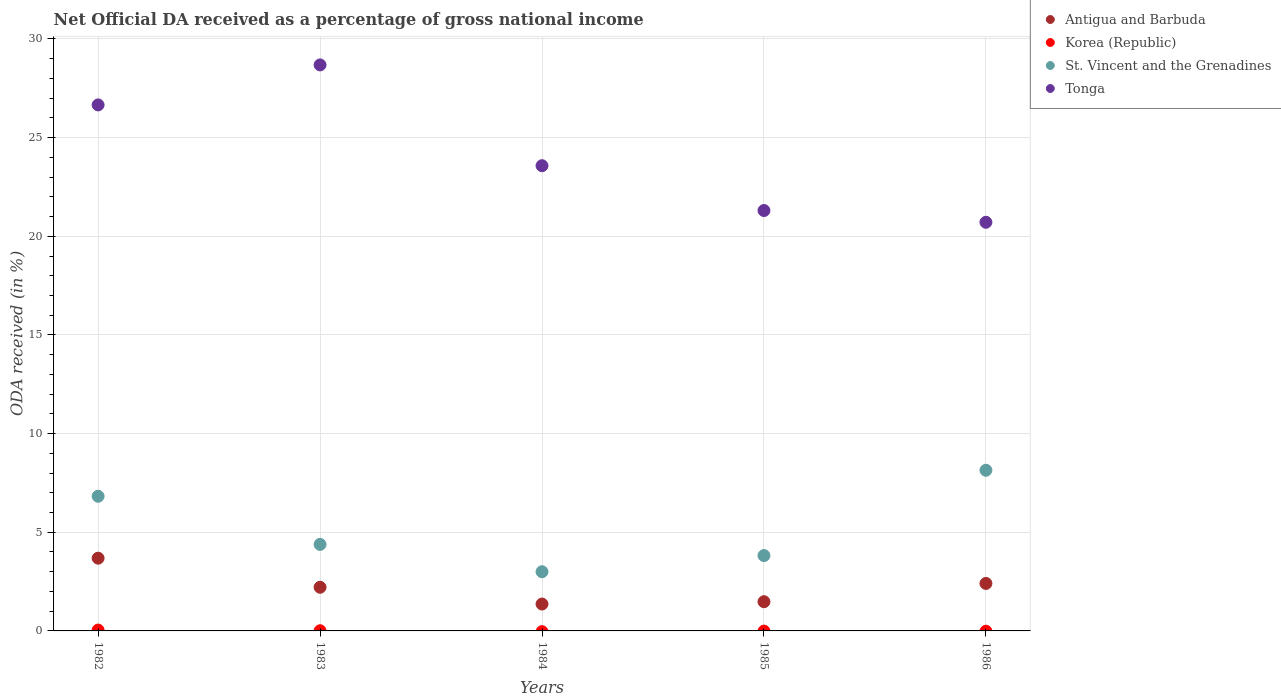Is the number of dotlines equal to the number of legend labels?
Provide a succinct answer. No. What is the net official DA received in Korea (Republic) in 1985?
Keep it short and to the point. 0. Across all years, what is the maximum net official DA received in St. Vincent and the Grenadines?
Offer a very short reply. 8.14. Across all years, what is the minimum net official DA received in Korea (Republic)?
Make the answer very short. 0. In which year was the net official DA received in Tonga maximum?
Give a very brief answer. 1983. What is the total net official DA received in St. Vincent and the Grenadines in the graph?
Offer a very short reply. 26.17. What is the difference between the net official DA received in Tonga in 1982 and that in 1983?
Give a very brief answer. -2.03. What is the difference between the net official DA received in St. Vincent and the Grenadines in 1984 and the net official DA received in Korea (Republic) in 1982?
Make the answer very short. 2.96. What is the average net official DA received in Antigua and Barbuda per year?
Provide a succinct answer. 2.23. In the year 1983, what is the difference between the net official DA received in Korea (Republic) and net official DA received in Antigua and Barbuda?
Your answer should be compact. -2.2. What is the ratio of the net official DA received in Korea (Republic) in 1982 to that in 1983?
Give a very brief answer. 4.91. Is the net official DA received in St. Vincent and the Grenadines in 1983 less than that in 1985?
Offer a very short reply. No. What is the difference between the highest and the second highest net official DA received in Antigua and Barbuda?
Give a very brief answer. 1.28. What is the difference between the highest and the lowest net official DA received in Antigua and Barbuda?
Make the answer very short. 2.32. In how many years, is the net official DA received in Tonga greater than the average net official DA received in Tonga taken over all years?
Ensure brevity in your answer.  2. Is it the case that in every year, the sum of the net official DA received in Antigua and Barbuda and net official DA received in Korea (Republic)  is greater than the sum of net official DA received in St. Vincent and the Grenadines and net official DA received in Tonga?
Offer a terse response. No. Is it the case that in every year, the sum of the net official DA received in Antigua and Barbuda and net official DA received in St. Vincent and the Grenadines  is greater than the net official DA received in Korea (Republic)?
Your answer should be compact. Yes. Is the net official DA received in Korea (Republic) strictly less than the net official DA received in Tonga over the years?
Your answer should be compact. Yes. How many years are there in the graph?
Offer a terse response. 5. What is the difference between two consecutive major ticks on the Y-axis?
Provide a short and direct response. 5. Are the values on the major ticks of Y-axis written in scientific E-notation?
Your answer should be compact. No. Does the graph contain any zero values?
Give a very brief answer. Yes. Where does the legend appear in the graph?
Offer a terse response. Top right. How are the legend labels stacked?
Your response must be concise. Vertical. What is the title of the graph?
Provide a short and direct response. Net Official DA received as a percentage of gross national income. Does "Czech Republic" appear as one of the legend labels in the graph?
Give a very brief answer. No. What is the label or title of the X-axis?
Provide a succinct answer. Years. What is the label or title of the Y-axis?
Provide a short and direct response. ODA received (in %). What is the ODA received (in %) of Antigua and Barbuda in 1982?
Provide a succinct answer. 3.69. What is the ODA received (in %) of Korea (Republic) in 1982?
Keep it short and to the point. 0.04. What is the ODA received (in %) of St. Vincent and the Grenadines in 1982?
Your answer should be very brief. 6.83. What is the ODA received (in %) in Tonga in 1982?
Keep it short and to the point. 26.66. What is the ODA received (in %) of Antigua and Barbuda in 1983?
Offer a terse response. 2.21. What is the ODA received (in %) of Korea (Republic) in 1983?
Give a very brief answer. 0.01. What is the ODA received (in %) of St. Vincent and the Grenadines in 1983?
Your answer should be compact. 4.38. What is the ODA received (in %) of Tonga in 1983?
Ensure brevity in your answer.  28.69. What is the ODA received (in %) in Antigua and Barbuda in 1984?
Your answer should be very brief. 1.36. What is the ODA received (in %) of St. Vincent and the Grenadines in 1984?
Offer a very short reply. 3. What is the ODA received (in %) of Tonga in 1984?
Provide a succinct answer. 23.58. What is the ODA received (in %) in Antigua and Barbuda in 1985?
Provide a short and direct response. 1.48. What is the ODA received (in %) of Korea (Republic) in 1985?
Your answer should be compact. 0. What is the ODA received (in %) in St. Vincent and the Grenadines in 1985?
Your response must be concise. 3.82. What is the ODA received (in %) of Tonga in 1985?
Keep it short and to the point. 21.31. What is the ODA received (in %) in Antigua and Barbuda in 1986?
Keep it short and to the point. 2.41. What is the ODA received (in %) of St. Vincent and the Grenadines in 1986?
Keep it short and to the point. 8.14. What is the ODA received (in %) in Tonga in 1986?
Your response must be concise. 20.71. Across all years, what is the maximum ODA received (in %) in Antigua and Barbuda?
Give a very brief answer. 3.69. Across all years, what is the maximum ODA received (in %) in Korea (Republic)?
Provide a succinct answer. 0.04. Across all years, what is the maximum ODA received (in %) of St. Vincent and the Grenadines?
Ensure brevity in your answer.  8.14. Across all years, what is the maximum ODA received (in %) of Tonga?
Make the answer very short. 28.69. Across all years, what is the minimum ODA received (in %) in Antigua and Barbuda?
Provide a succinct answer. 1.36. Across all years, what is the minimum ODA received (in %) in St. Vincent and the Grenadines?
Offer a terse response. 3. Across all years, what is the minimum ODA received (in %) in Tonga?
Make the answer very short. 20.71. What is the total ODA received (in %) in Antigua and Barbuda in the graph?
Your answer should be compact. 11.15. What is the total ODA received (in %) of Korea (Republic) in the graph?
Your response must be concise. 0.05. What is the total ODA received (in %) of St. Vincent and the Grenadines in the graph?
Keep it short and to the point. 26.17. What is the total ODA received (in %) of Tonga in the graph?
Provide a succinct answer. 120.94. What is the difference between the ODA received (in %) in Antigua and Barbuda in 1982 and that in 1983?
Your answer should be compact. 1.47. What is the difference between the ODA received (in %) in Korea (Republic) in 1982 and that in 1983?
Your response must be concise. 0.03. What is the difference between the ODA received (in %) of St. Vincent and the Grenadines in 1982 and that in 1983?
Keep it short and to the point. 2.44. What is the difference between the ODA received (in %) in Tonga in 1982 and that in 1983?
Provide a short and direct response. -2.03. What is the difference between the ODA received (in %) in Antigua and Barbuda in 1982 and that in 1984?
Make the answer very short. 2.32. What is the difference between the ODA received (in %) of St. Vincent and the Grenadines in 1982 and that in 1984?
Provide a short and direct response. 3.83. What is the difference between the ODA received (in %) in Tonga in 1982 and that in 1984?
Your answer should be compact. 3.08. What is the difference between the ODA received (in %) in Antigua and Barbuda in 1982 and that in 1985?
Ensure brevity in your answer.  2.21. What is the difference between the ODA received (in %) in St. Vincent and the Grenadines in 1982 and that in 1985?
Your answer should be compact. 3.01. What is the difference between the ODA received (in %) in Tonga in 1982 and that in 1985?
Your answer should be very brief. 5.35. What is the difference between the ODA received (in %) in Antigua and Barbuda in 1982 and that in 1986?
Offer a terse response. 1.28. What is the difference between the ODA received (in %) in St. Vincent and the Grenadines in 1982 and that in 1986?
Give a very brief answer. -1.32. What is the difference between the ODA received (in %) of Tonga in 1982 and that in 1986?
Your response must be concise. 5.95. What is the difference between the ODA received (in %) of Antigua and Barbuda in 1983 and that in 1984?
Provide a succinct answer. 0.85. What is the difference between the ODA received (in %) of St. Vincent and the Grenadines in 1983 and that in 1984?
Your answer should be very brief. 1.39. What is the difference between the ODA received (in %) in Tonga in 1983 and that in 1984?
Provide a succinct answer. 5.11. What is the difference between the ODA received (in %) of Antigua and Barbuda in 1983 and that in 1985?
Give a very brief answer. 0.73. What is the difference between the ODA received (in %) of St. Vincent and the Grenadines in 1983 and that in 1985?
Provide a short and direct response. 0.57. What is the difference between the ODA received (in %) in Tonga in 1983 and that in 1985?
Your response must be concise. 7.38. What is the difference between the ODA received (in %) of Antigua and Barbuda in 1983 and that in 1986?
Offer a very short reply. -0.19. What is the difference between the ODA received (in %) of St. Vincent and the Grenadines in 1983 and that in 1986?
Offer a terse response. -3.76. What is the difference between the ODA received (in %) in Tonga in 1983 and that in 1986?
Give a very brief answer. 7.98. What is the difference between the ODA received (in %) in Antigua and Barbuda in 1984 and that in 1985?
Your answer should be compact. -0.12. What is the difference between the ODA received (in %) in St. Vincent and the Grenadines in 1984 and that in 1985?
Your response must be concise. -0.82. What is the difference between the ODA received (in %) of Tonga in 1984 and that in 1985?
Make the answer very short. 2.27. What is the difference between the ODA received (in %) in Antigua and Barbuda in 1984 and that in 1986?
Give a very brief answer. -1.04. What is the difference between the ODA received (in %) in St. Vincent and the Grenadines in 1984 and that in 1986?
Offer a terse response. -5.14. What is the difference between the ODA received (in %) in Tonga in 1984 and that in 1986?
Give a very brief answer. 2.87. What is the difference between the ODA received (in %) of Antigua and Barbuda in 1985 and that in 1986?
Give a very brief answer. -0.92. What is the difference between the ODA received (in %) in St. Vincent and the Grenadines in 1985 and that in 1986?
Provide a succinct answer. -4.32. What is the difference between the ODA received (in %) of Tonga in 1985 and that in 1986?
Your response must be concise. 0.6. What is the difference between the ODA received (in %) of Antigua and Barbuda in 1982 and the ODA received (in %) of Korea (Republic) in 1983?
Provide a succinct answer. 3.68. What is the difference between the ODA received (in %) in Antigua and Barbuda in 1982 and the ODA received (in %) in St. Vincent and the Grenadines in 1983?
Provide a short and direct response. -0.7. What is the difference between the ODA received (in %) in Antigua and Barbuda in 1982 and the ODA received (in %) in Tonga in 1983?
Offer a very short reply. -25. What is the difference between the ODA received (in %) in Korea (Republic) in 1982 and the ODA received (in %) in St. Vincent and the Grenadines in 1983?
Provide a succinct answer. -4.34. What is the difference between the ODA received (in %) in Korea (Republic) in 1982 and the ODA received (in %) in Tonga in 1983?
Your answer should be compact. -28.64. What is the difference between the ODA received (in %) in St. Vincent and the Grenadines in 1982 and the ODA received (in %) in Tonga in 1983?
Give a very brief answer. -21.86. What is the difference between the ODA received (in %) in Antigua and Barbuda in 1982 and the ODA received (in %) in St. Vincent and the Grenadines in 1984?
Ensure brevity in your answer.  0.69. What is the difference between the ODA received (in %) of Antigua and Barbuda in 1982 and the ODA received (in %) of Tonga in 1984?
Offer a terse response. -19.89. What is the difference between the ODA received (in %) of Korea (Republic) in 1982 and the ODA received (in %) of St. Vincent and the Grenadines in 1984?
Your answer should be very brief. -2.96. What is the difference between the ODA received (in %) of Korea (Republic) in 1982 and the ODA received (in %) of Tonga in 1984?
Provide a succinct answer. -23.54. What is the difference between the ODA received (in %) of St. Vincent and the Grenadines in 1982 and the ODA received (in %) of Tonga in 1984?
Make the answer very short. -16.75. What is the difference between the ODA received (in %) of Antigua and Barbuda in 1982 and the ODA received (in %) of St. Vincent and the Grenadines in 1985?
Provide a succinct answer. -0.13. What is the difference between the ODA received (in %) of Antigua and Barbuda in 1982 and the ODA received (in %) of Tonga in 1985?
Your response must be concise. -17.62. What is the difference between the ODA received (in %) in Korea (Republic) in 1982 and the ODA received (in %) in St. Vincent and the Grenadines in 1985?
Your answer should be compact. -3.78. What is the difference between the ODA received (in %) of Korea (Republic) in 1982 and the ODA received (in %) of Tonga in 1985?
Your answer should be very brief. -21.26. What is the difference between the ODA received (in %) in St. Vincent and the Grenadines in 1982 and the ODA received (in %) in Tonga in 1985?
Offer a terse response. -14.48. What is the difference between the ODA received (in %) of Antigua and Barbuda in 1982 and the ODA received (in %) of St. Vincent and the Grenadines in 1986?
Your answer should be compact. -4.46. What is the difference between the ODA received (in %) of Antigua and Barbuda in 1982 and the ODA received (in %) of Tonga in 1986?
Your answer should be compact. -17.02. What is the difference between the ODA received (in %) of Korea (Republic) in 1982 and the ODA received (in %) of St. Vincent and the Grenadines in 1986?
Offer a very short reply. -8.1. What is the difference between the ODA received (in %) in Korea (Republic) in 1982 and the ODA received (in %) in Tonga in 1986?
Offer a terse response. -20.67. What is the difference between the ODA received (in %) in St. Vincent and the Grenadines in 1982 and the ODA received (in %) in Tonga in 1986?
Provide a short and direct response. -13.89. What is the difference between the ODA received (in %) of Antigua and Barbuda in 1983 and the ODA received (in %) of St. Vincent and the Grenadines in 1984?
Make the answer very short. -0.79. What is the difference between the ODA received (in %) of Antigua and Barbuda in 1983 and the ODA received (in %) of Tonga in 1984?
Make the answer very short. -21.36. What is the difference between the ODA received (in %) of Korea (Republic) in 1983 and the ODA received (in %) of St. Vincent and the Grenadines in 1984?
Provide a short and direct response. -2.99. What is the difference between the ODA received (in %) in Korea (Republic) in 1983 and the ODA received (in %) in Tonga in 1984?
Ensure brevity in your answer.  -23.57. What is the difference between the ODA received (in %) of St. Vincent and the Grenadines in 1983 and the ODA received (in %) of Tonga in 1984?
Your answer should be compact. -19.19. What is the difference between the ODA received (in %) in Antigua and Barbuda in 1983 and the ODA received (in %) in St. Vincent and the Grenadines in 1985?
Your answer should be compact. -1.61. What is the difference between the ODA received (in %) of Antigua and Barbuda in 1983 and the ODA received (in %) of Tonga in 1985?
Your answer should be compact. -19.09. What is the difference between the ODA received (in %) of Korea (Republic) in 1983 and the ODA received (in %) of St. Vincent and the Grenadines in 1985?
Provide a short and direct response. -3.81. What is the difference between the ODA received (in %) of Korea (Republic) in 1983 and the ODA received (in %) of Tonga in 1985?
Your answer should be very brief. -21.3. What is the difference between the ODA received (in %) of St. Vincent and the Grenadines in 1983 and the ODA received (in %) of Tonga in 1985?
Your answer should be compact. -16.92. What is the difference between the ODA received (in %) of Antigua and Barbuda in 1983 and the ODA received (in %) of St. Vincent and the Grenadines in 1986?
Keep it short and to the point. -5.93. What is the difference between the ODA received (in %) in Antigua and Barbuda in 1983 and the ODA received (in %) in Tonga in 1986?
Your response must be concise. -18.5. What is the difference between the ODA received (in %) of Korea (Republic) in 1983 and the ODA received (in %) of St. Vincent and the Grenadines in 1986?
Your answer should be compact. -8.13. What is the difference between the ODA received (in %) in Korea (Republic) in 1983 and the ODA received (in %) in Tonga in 1986?
Your answer should be very brief. -20.7. What is the difference between the ODA received (in %) in St. Vincent and the Grenadines in 1983 and the ODA received (in %) in Tonga in 1986?
Your answer should be compact. -16.33. What is the difference between the ODA received (in %) of Antigua and Barbuda in 1984 and the ODA received (in %) of St. Vincent and the Grenadines in 1985?
Give a very brief answer. -2.46. What is the difference between the ODA received (in %) in Antigua and Barbuda in 1984 and the ODA received (in %) in Tonga in 1985?
Offer a very short reply. -19.94. What is the difference between the ODA received (in %) in St. Vincent and the Grenadines in 1984 and the ODA received (in %) in Tonga in 1985?
Provide a short and direct response. -18.31. What is the difference between the ODA received (in %) in Antigua and Barbuda in 1984 and the ODA received (in %) in St. Vincent and the Grenadines in 1986?
Ensure brevity in your answer.  -6.78. What is the difference between the ODA received (in %) in Antigua and Barbuda in 1984 and the ODA received (in %) in Tonga in 1986?
Make the answer very short. -19.35. What is the difference between the ODA received (in %) in St. Vincent and the Grenadines in 1984 and the ODA received (in %) in Tonga in 1986?
Ensure brevity in your answer.  -17.71. What is the difference between the ODA received (in %) in Antigua and Barbuda in 1985 and the ODA received (in %) in St. Vincent and the Grenadines in 1986?
Ensure brevity in your answer.  -6.66. What is the difference between the ODA received (in %) in Antigua and Barbuda in 1985 and the ODA received (in %) in Tonga in 1986?
Provide a succinct answer. -19.23. What is the difference between the ODA received (in %) of St. Vincent and the Grenadines in 1985 and the ODA received (in %) of Tonga in 1986?
Give a very brief answer. -16.89. What is the average ODA received (in %) of Antigua and Barbuda per year?
Your answer should be very brief. 2.23. What is the average ODA received (in %) of Korea (Republic) per year?
Offer a terse response. 0.01. What is the average ODA received (in %) in St. Vincent and the Grenadines per year?
Ensure brevity in your answer.  5.23. What is the average ODA received (in %) in Tonga per year?
Your response must be concise. 24.19. In the year 1982, what is the difference between the ODA received (in %) in Antigua and Barbuda and ODA received (in %) in Korea (Republic)?
Provide a short and direct response. 3.64. In the year 1982, what is the difference between the ODA received (in %) of Antigua and Barbuda and ODA received (in %) of St. Vincent and the Grenadines?
Your answer should be compact. -3.14. In the year 1982, what is the difference between the ODA received (in %) of Antigua and Barbuda and ODA received (in %) of Tonga?
Offer a very short reply. -22.97. In the year 1982, what is the difference between the ODA received (in %) in Korea (Republic) and ODA received (in %) in St. Vincent and the Grenadines?
Your answer should be very brief. -6.78. In the year 1982, what is the difference between the ODA received (in %) of Korea (Republic) and ODA received (in %) of Tonga?
Your response must be concise. -26.62. In the year 1982, what is the difference between the ODA received (in %) in St. Vincent and the Grenadines and ODA received (in %) in Tonga?
Keep it short and to the point. -19.83. In the year 1983, what is the difference between the ODA received (in %) of Antigua and Barbuda and ODA received (in %) of Korea (Republic)?
Make the answer very short. 2.2. In the year 1983, what is the difference between the ODA received (in %) of Antigua and Barbuda and ODA received (in %) of St. Vincent and the Grenadines?
Your answer should be compact. -2.17. In the year 1983, what is the difference between the ODA received (in %) in Antigua and Barbuda and ODA received (in %) in Tonga?
Offer a terse response. -26.47. In the year 1983, what is the difference between the ODA received (in %) of Korea (Republic) and ODA received (in %) of St. Vincent and the Grenadines?
Offer a terse response. -4.38. In the year 1983, what is the difference between the ODA received (in %) of Korea (Republic) and ODA received (in %) of Tonga?
Offer a terse response. -28.68. In the year 1983, what is the difference between the ODA received (in %) in St. Vincent and the Grenadines and ODA received (in %) in Tonga?
Provide a succinct answer. -24.3. In the year 1984, what is the difference between the ODA received (in %) in Antigua and Barbuda and ODA received (in %) in St. Vincent and the Grenadines?
Provide a succinct answer. -1.64. In the year 1984, what is the difference between the ODA received (in %) of Antigua and Barbuda and ODA received (in %) of Tonga?
Your response must be concise. -22.21. In the year 1984, what is the difference between the ODA received (in %) of St. Vincent and the Grenadines and ODA received (in %) of Tonga?
Make the answer very short. -20.58. In the year 1985, what is the difference between the ODA received (in %) in Antigua and Barbuda and ODA received (in %) in St. Vincent and the Grenadines?
Ensure brevity in your answer.  -2.34. In the year 1985, what is the difference between the ODA received (in %) in Antigua and Barbuda and ODA received (in %) in Tonga?
Keep it short and to the point. -19.83. In the year 1985, what is the difference between the ODA received (in %) in St. Vincent and the Grenadines and ODA received (in %) in Tonga?
Give a very brief answer. -17.49. In the year 1986, what is the difference between the ODA received (in %) in Antigua and Barbuda and ODA received (in %) in St. Vincent and the Grenadines?
Provide a short and direct response. -5.74. In the year 1986, what is the difference between the ODA received (in %) in Antigua and Barbuda and ODA received (in %) in Tonga?
Your answer should be compact. -18.31. In the year 1986, what is the difference between the ODA received (in %) of St. Vincent and the Grenadines and ODA received (in %) of Tonga?
Make the answer very short. -12.57. What is the ratio of the ODA received (in %) of Antigua and Barbuda in 1982 to that in 1983?
Make the answer very short. 1.67. What is the ratio of the ODA received (in %) in Korea (Republic) in 1982 to that in 1983?
Ensure brevity in your answer.  4.91. What is the ratio of the ODA received (in %) in St. Vincent and the Grenadines in 1982 to that in 1983?
Offer a very short reply. 1.56. What is the ratio of the ODA received (in %) of Tonga in 1982 to that in 1983?
Offer a very short reply. 0.93. What is the ratio of the ODA received (in %) in Antigua and Barbuda in 1982 to that in 1984?
Provide a succinct answer. 2.7. What is the ratio of the ODA received (in %) of St. Vincent and the Grenadines in 1982 to that in 1984?
Your answer should be compact. 2.28. What is the ratio of the ODA received (in %) of Tonga in 1982 to that in 1984?
Provide a short and direct response. 1.13. What is the ratio of the ODA received (in %) of Antigua and Barbuda in 1982 to that in 1985?
Make the answer very short. 2.49. What is the ratio of the ODA received (in %) of St. Vincent and the Grenadines in 1982 to that in 1985?
Provide a succinct answer. 1.79. What is the ratio of the ODA received (in %) in Tonga in 1982 to that in 1985?
Your answer should be compact. 1.25. What is the ratio of the ODA received (in %) of Antigua and Barbuda in 1982 to that in 1986?
Keep it short and to the point. 1.53. What is the ratio of the ODA received (in %) in St. Vincent and the Grenadines in 1982 to that in 1986?
Give a very brief answer. 0.84. What is the ratio of the ODA received (in %) in Tonga in 1982 to that in 1986?
Your answer should be very brief. 1.29. What is the ratio of the ODA received (in %) of Antigua and Barbuda in 1983 to that in 1984?
Provide a short and direct response. 1.62. What is the ratio of the ODA received (in %) in St. Vincent and the Grenadines in 1983 to that in 1984?
Make the answer very short. 1.46. What is the ratio of the ODA received (in %) of Tonga in 1983 to that in 1984?
Offer a very short reply. 1.22. What is the ratio of the ODA received (in %) in Antigua and Barbuda in 1983 to that in 1985?
Make the answer very short. 1.49. What is the ratio of the ODA received (in %) of St. Vincent and the Grenadines in 1983 to that in 1985?
Offer a terse response. 1.15. What is the ratio of the ODA received (in %) in Tonga in 1983 to that in 1985?
Provide a short and direct response. 1.35. What is the ratio of the ODA received (in %) of Antigua and Barbuda in 1983 to that in 1986?
Offer a very short reply. 0.92. What is the ratio of the ODA received (in %) of St. Vincent and the Grenadines in 1983 to that in 1986?
Offer a very short reply. 0.54. What is the ratio of the ODA received (in %) in Tonga in 1983 to that in 1986?
Provide a succinct answer. 1.39. What is the ratio of the ODA received (in %) in Antigua and Barbuda in 1984 to that in 1985?
Provide a succinct answer. 0.92. What is the ratio of the ODA received (in %) of St. Vincent and the Grenadines in 1984 to that in 1985?
Your response must be concise. 0.79. What is the ratio of the ODA received (in %) of Tonga in 1984 to that in 1985?
Your answer should be compact. 1.11. What is the ratio of the ODA received (in %) of Antigua and Barbuda in 1984 to that in 1986?
Your answer should be very brief. 0.57. What is the ratio of the ODA received (in %) in St. Vincent and the Grenadines in 1984 to that in 1986?
Keep it short and to the point. 0.37. What is the ratio of the ODA received (in %) in Tonga in 1984 to that in 1986?
Offer a very short reply. 1.14. What is the ratio of the ODA received (in %) of Antigua and Barbuda in 1985 to that in 1986?
Offer a terse response. 0.62. What is the ratio of the ODA received (in %) in St. Vincent and the Grenadines in 1985 to that in 1986?
Offer a very short reply. 0.47. What is the ratio of the ODA received (in %) in Tonga in 1985 to that in 1986?
Your response must be concise. 1.03. What is the difference between the highest and the second highest ODA received (in %) in Antigua and Barbuda?
Give a very brief answer. 1.28. What is the difference between the highest and the second highest ODA received (in %) of St. Vincent and the Grenadines?
Provide a short and direct response. 1.32. What is the difference between the highest and the second highest ODA received (in %) in Tonga?
Give a very brief answer. 2.03. What is the difference between the highest and the lowest ODA received (in %) of Antigua and Barbuda?
Provide a short and direct response. 2.32. What is the difference between the highest and the lowest ODA received (in %) of Korea (Republic)?
Ensure brevity in your answer.  0.04. What is the difference between the highest and the lowest ODA received (in %) of St. Vincent and the Grenadines?
Keep it short and to the point. 5.14. What is the difference between the highest and the lowest ODA received (in %) in Tonga?
Your answer should be very brief. 7.98. 